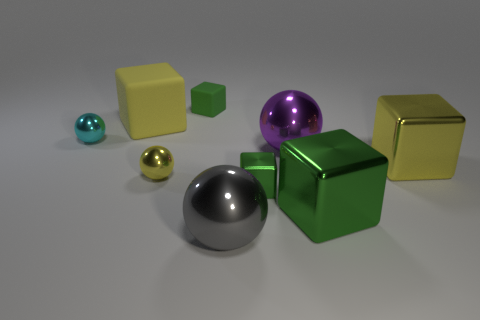Subtract all metallic cubes. How many cubes are left? 2 Add 1 cyan metallic spheres. How many objects exist? 10 Subtract all yellow cubes. How many cubes are left? 3 Subtract 2 cubes. How many cubes are left? 3 Subtract all cyan cylinders. How many yellow blocks are left? 2 Subtract all cubes. How many objects are left? 4 Subtract 0 red blocks. How many objects are left? 9 Subtract all red balls. Subtract all green blocks. How many balls are left? 4 Subtract all large cyan rubber cylinders. Subtract all small yellow metal spheres. How many objects are left? 8 Add 4 small cyan balls. How many small cyan balls are left? 5 